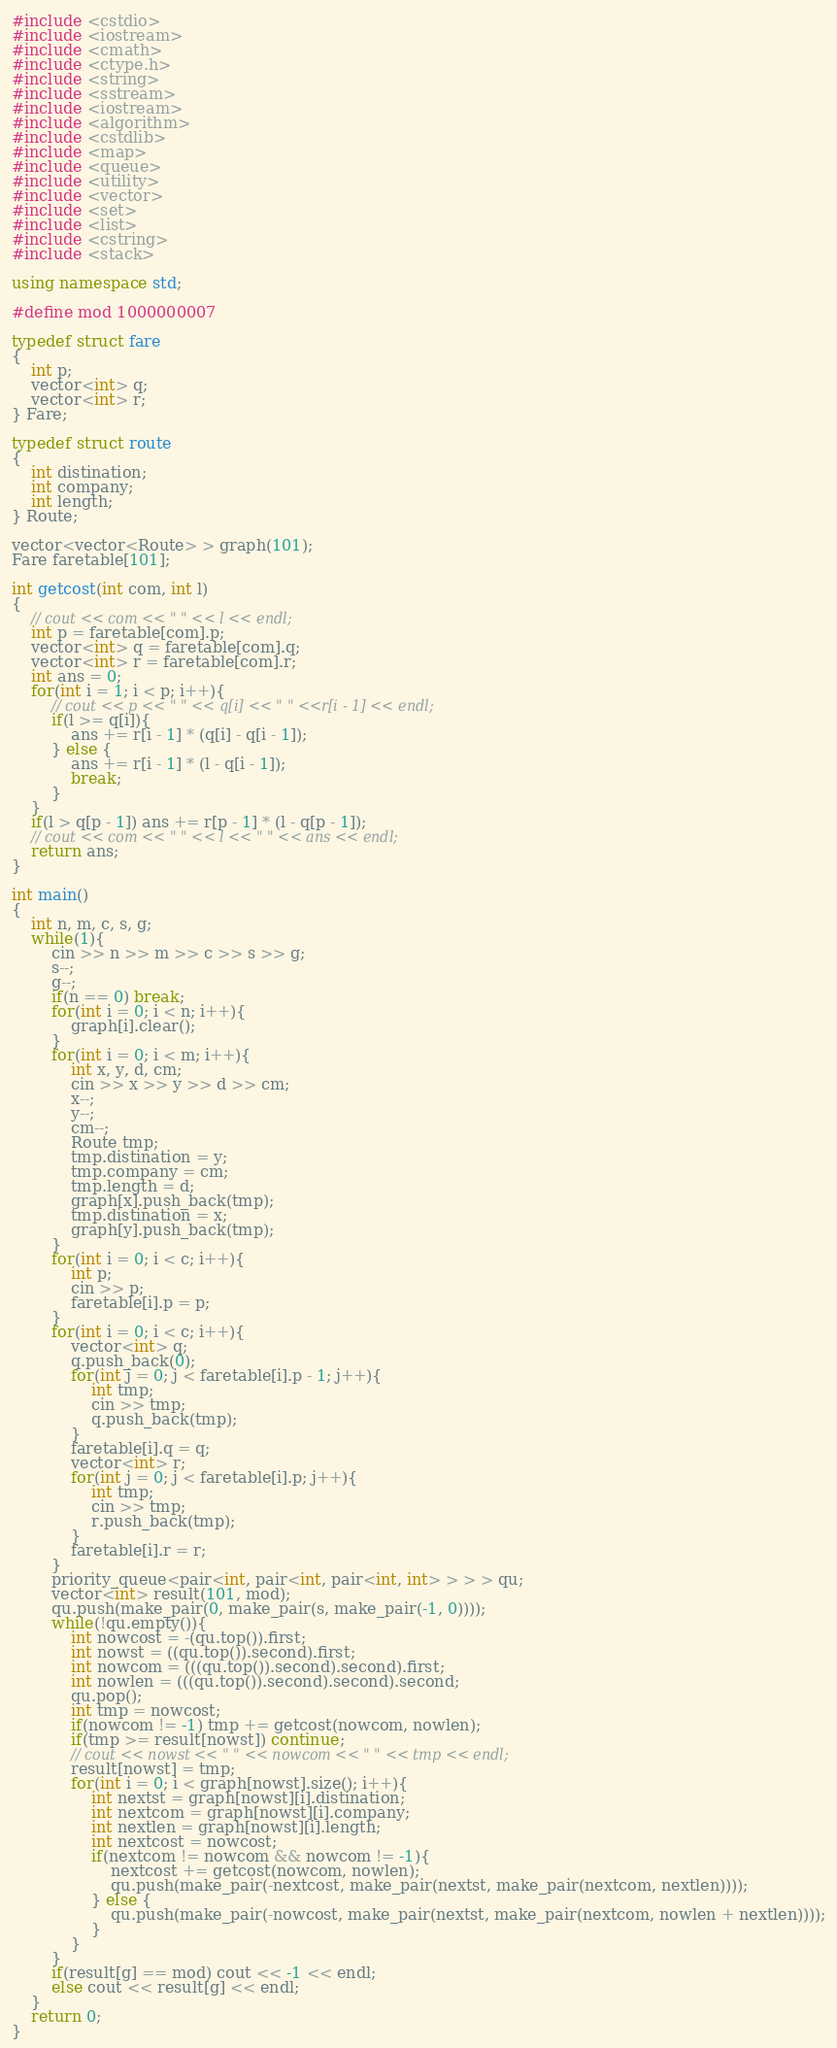<code> <loc_0><loc_0><loc_500><loc_500><_C++_>#include <cstdio>
#include <iostream>
#include <cmath>
#include <ctype.h>
#include <string>
#include <sstream>
#include <iostream>
#include <algorithm>
#include <cstdlib>
#include <map>
#include <queue>
#include <utility>
#include <vector>
#include <set>
#include <list>
#include <cstring>
#include <stack>

using namespace std;

#define mod 1000000007

typedef struct fare
{
	int p;
	vector<int> q;
	vector<int> r;
} Fare;

typedef struct route
{
	int distination;
	int company;
	int length;
} Route;

vector<vector<Route> > graph(101);
Fare faretable[101];

int getcost(int com, int l)
{
	// cout << com << " " << l << endl;
	int p = faretable[com].p;
	vector<int> q = faretable[com].q;
	vector<int> r = faretable[com].r;
	int ans = 0;
	for(int i = 1; i < p; i++){
		// cout << p << " " << q[i] << " " <<r[i - 1] << endl;
		if(l >= q[i]){
			ans += r[i - 1] * (q[i] - q[i - 1]);
		} else {
			ans += r[i - 1] * (l - q[i - 1]);
			break;
		}
	}
	if(l > q[p - 1]) ans += r[p - 1] * (l - q[p - 1]);
	// cout << com << " " << l << " " << ans << endl;
	return ans;
}

int main()
{
	int n, m, c, s, g;
	while(1){
		cin >> n >> m >> c >> s >> g;
		s--;
		g--;
		if(n == 0) break;
		for(int i = 0; i < n; i++){
			graph[i].clear();
		}
		for(int i = 0; i < m; i++){
			int x, y, d, cm;
			cin >> x >> y >> d >> cm;
			x--;
			y--;
			cm--;
			Route tmp;
			tmp.distination = y;
			tmp.company = cm;
			tmp.length = d;
			graph[x].push_back(tmp);
			tmp.distination = x;
			graph[y].push_back(tmp);
		}
		for(int i = 0; i < c; i++){
			int p;
			cin >> p;
			faretable[i].p = p;
		}
		for(int i = 0; i < c; i++){
			vector<int> q;
			q.push_back(0);
			for(int j = 0; j < faretable[i].p - 1; j++){
				int tmp;
				cin >> tmp;
				q.push_back(tmp);
			}
			faretable[i].q = q;
			vector<int> r;
			for(int j = 0; j < faretable[i].p; j++){
				int tmp;
				cin >> tmp;
				r.push_back(tmp);
			}
			faretable[i].r = r;
		}
		priority_queue<pair<int, pair<int, pair<int, int> > > > qu;
		vector<int> result(101, mod);
		qu.push(make_pair(0, make_pair(s, make_pair(-1, 0))));
		while(!qu.empty()){
			int nowcost = -(qu.top()).first;
			int nowst = ((qu.top()).second).first;
			int nowcom = (((qu.top()).second).second).first;
			int nowlen = (((qu.top()).second).second).second;
			qu.pop();
			int tmp = nowcost;
			if(nowcom != -1) tmp += getcost(nowcom, nowlen);
			if(tmp >= result[nowst]) continue;
			// cout << nowst << " " << nowcom << " " << tmp << endl;
			result[nowst] = tmp;
			for(int i = 0; i < graph[nowst].size(); i++){
				int nextst = graph[nowst][i].distination;
				int nextcom = graph[nowst][i].company;
				int nextlen = graph[nowst][i].length;
				int nextcost = nowcost;
				if(nextcom != nowcom && nowcom != -1){
					nextcost += getcost(nowcom, nowlen);
					qu.push(make_pair(-nextcost, make_pair(nextst, make_pair(nextcom, nextlen))));
				} else {
					qu.push(make_pair(-nowcost, make_pair(nextst, make_pair(nextcom, nowlen + nextlen))));
				}
			}
		}
		if(result[g] == mod) cout << -1 << endl;
		else cout << result[g] << endl;
	}
	return 0;
}</code> 